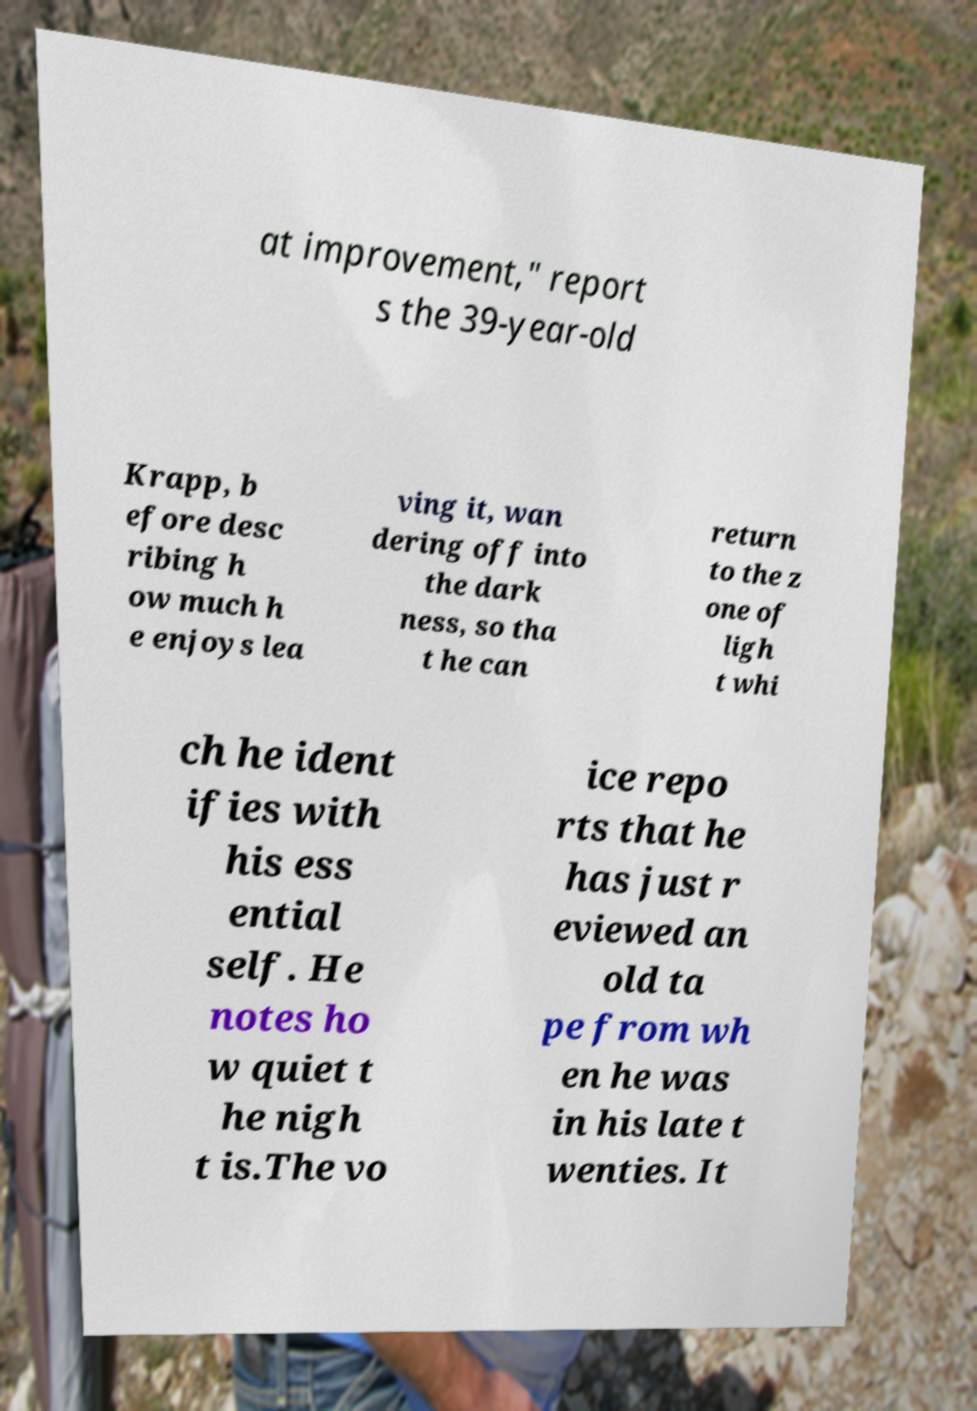Can you accurately transcribe the text from the provided image for me? at improvement," report s the 39-year-old Krapp, b efore desc ribing h ow much h e enjoys lea ving it, wan dering off into the dark ness, so tha t he can return to the z one of ligh t whi ch he ident ifies with his ess ential self. He notes ho w quiet t he nigh t is.The vo ice repo rts that he has just r eviewed an old ta pe from wh en he was in his late t wenties. It 